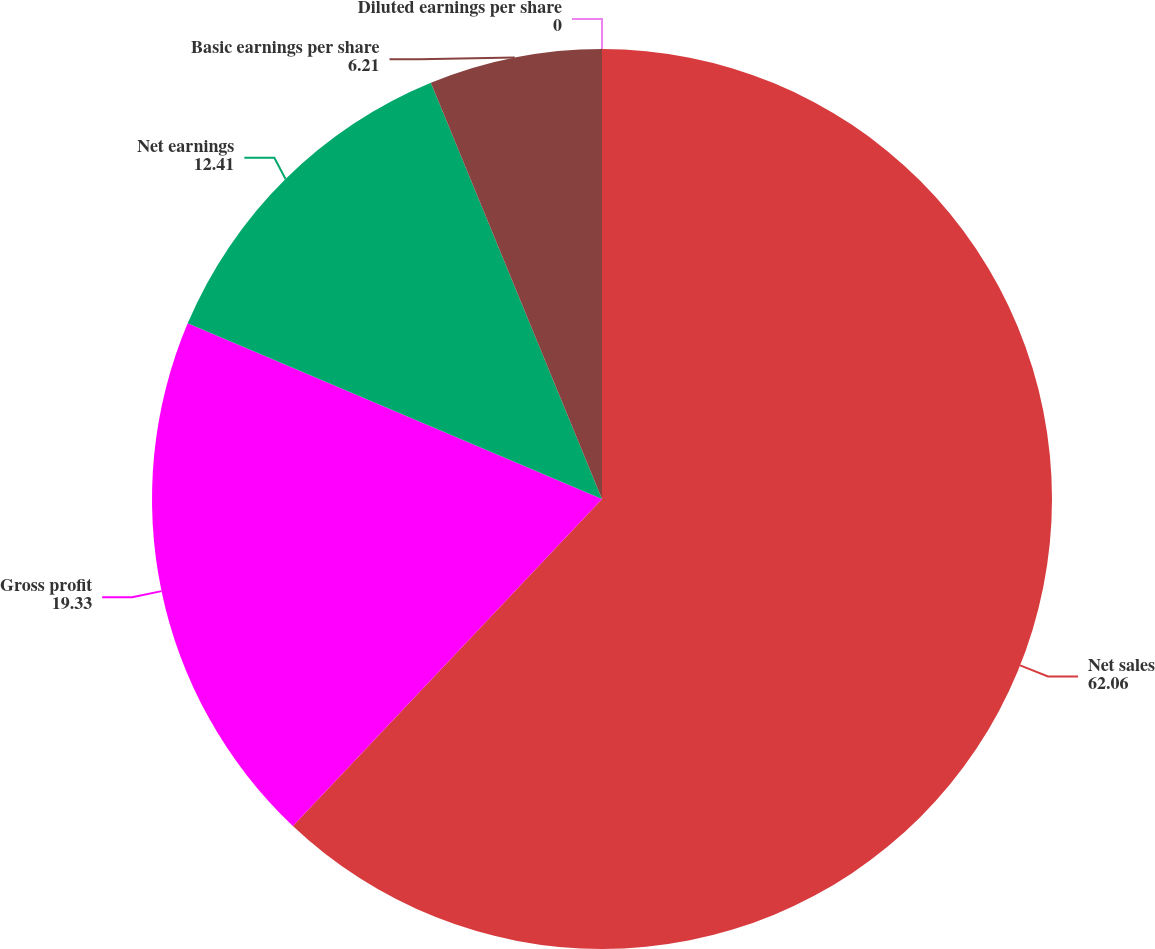Convert chart to OTSL. <chart><loc_0><loc_0><loc_500><loc_500><pie_chart><fcel>Net sales<fcel>Gross profit<fcel>Net earnings<fcel>Basic earnings per share<fcel>Diluted earnings per share<nl><fcel>62.06%<fcel>19.33%<fcel>12.41%<fcel>6.21%<fcel>0.0%<nl></chart> 